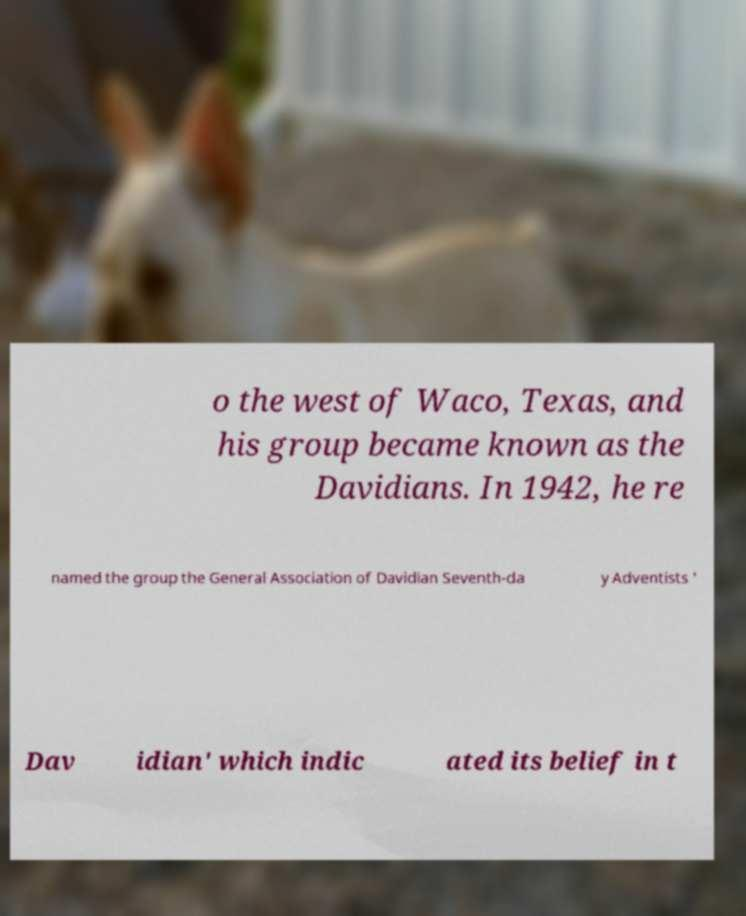Please identify and transcribe the text found in this image. o the west of Waco, Texas, and his group became known as the Davidians. In 1942, he re named the group the General Association of Davidian Seventh-da y Adventists ' Dav idian' which indic ated its belief in t 